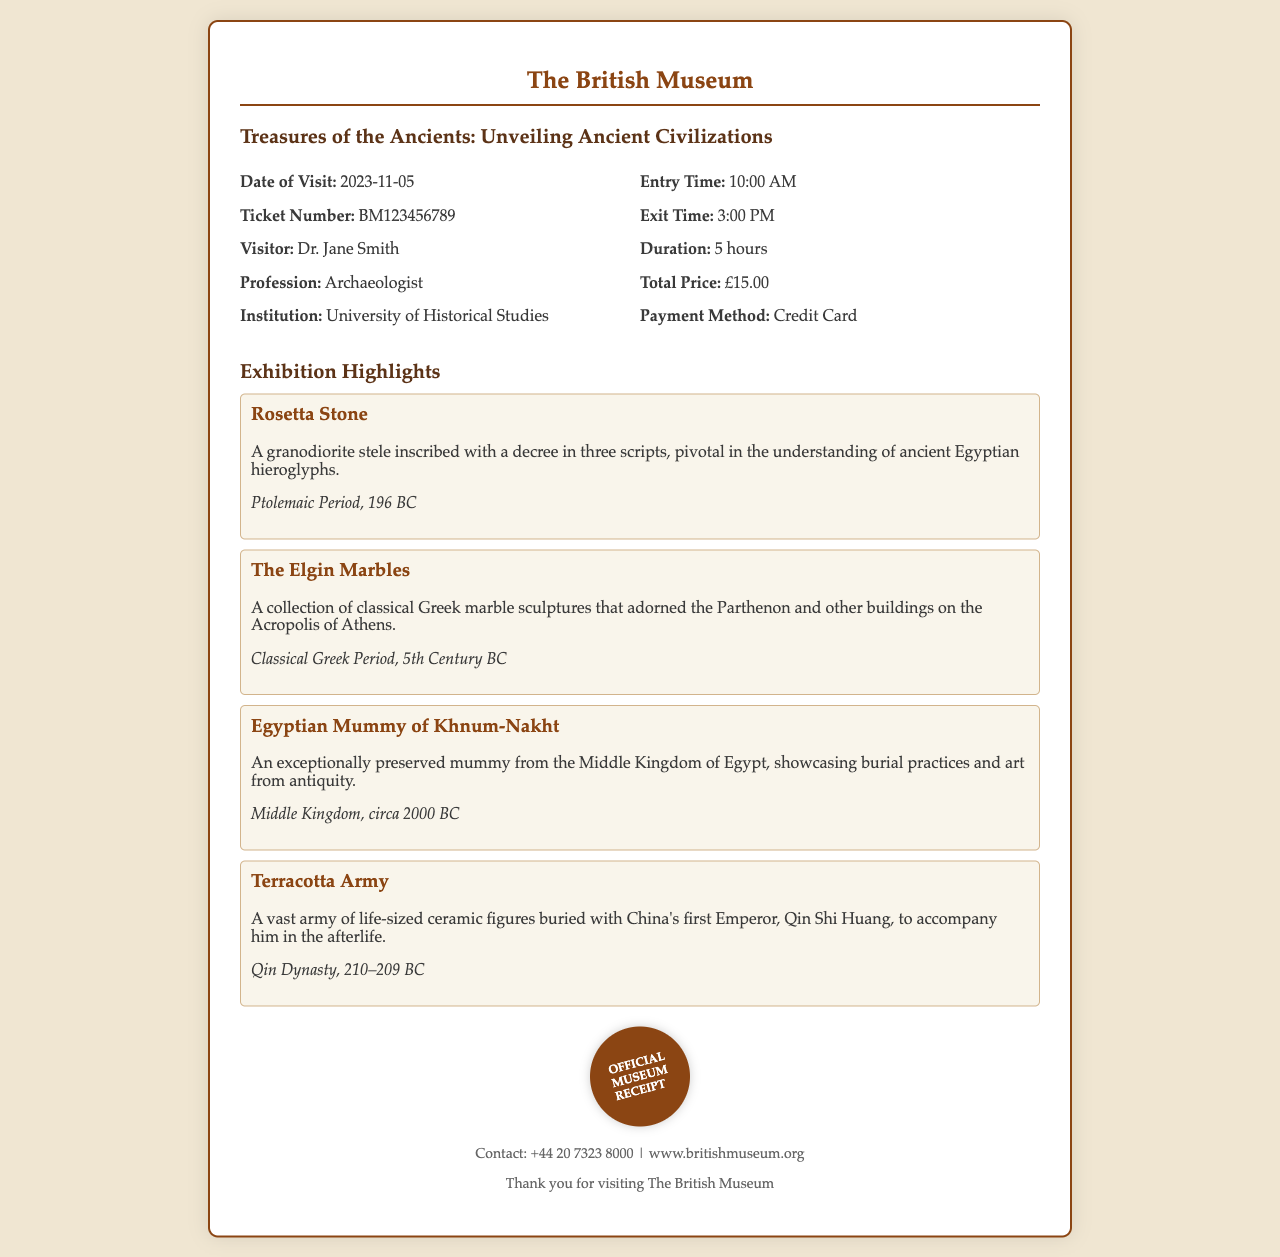What is the title of the exhibition? The title can be found at the top of the receipt, which states the name of the exhibition.
Answer: Treasures of the Ancients: Unveiling Ancient Civilizations When is the date of visit? The date of visit is clearly mentioned in the document under visitor information.
Answer: 2023-11-05 Who is the ticket issued to? The name of the visitor is listed in the receipt under the visitor information.
Answer: Dr. Jane Smith What is the total price of the ticket? The total price is specified in the section detailing ticket details and costs.
Answer: £15.00 What artifact is associated with the Ptolemaic Period? The exhibition highlights include artifacts with their historical periods listed, such as this one.
Answer: Rosetta Stone What was the exit time from the exhibition? The exit time is provided alongside the entry time in visitor information.
Answer: 3:00 PM How long did the visitor stay at the exhibition? The duration of the visit is specified in the document.
Answer: 5 hours What collection adorns the Parthenon? Referring to the exhibition highlights, the collection related to this question is mentioned.
Answer: The Elgin Marbles What institution is Dr. Jane Smith affiliated with? The document lists the institution associated with the visitor.
Answer: University of Historical Studies 